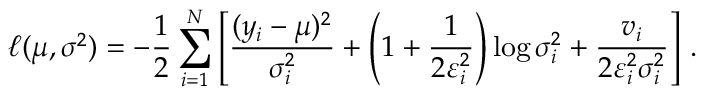<formula> <loc_0><loc_0><loc_500><loc_500>\ell ( \mu , \sigma ^ { 2 } ) = - \frac { 1 } { 2 } \sum _ { i = 1 } ^ { N } \left [ \frac { ( y _ { i } - \mu ) ^ { 2 } } { \sigma _ { i } ^ { 2 } } + \left ( 1 + \frac { 1 } { 2 \varepsilon _ { i } ^ { 2 } } \right ) \log { \sigma _ { i } ^ { 2 } } + \frac { v _ { i } } { 2 \varepsilon _ { i } ^ { 2 } \sigma _ { i } ^ { 2 } } \right ] \, .</formula> 